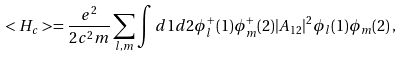<formula> <loc_0><loc_0><loc_500><loc_500>< H _ { c } > = \frac { e ^ { 2 } } { 2 c ^ { 2 } m } \sum _ { l , m } \int d 1 d 2 \phi _ { l } ^ { + } ( 1 ) \phi _ { m } ^ { + } ( 2 ) | { A } _ { 1 2 } | ^ { 2 } \phi _ { l } ( 1 ) \phi _ { m } ( 2 ) \, ,</formula> 